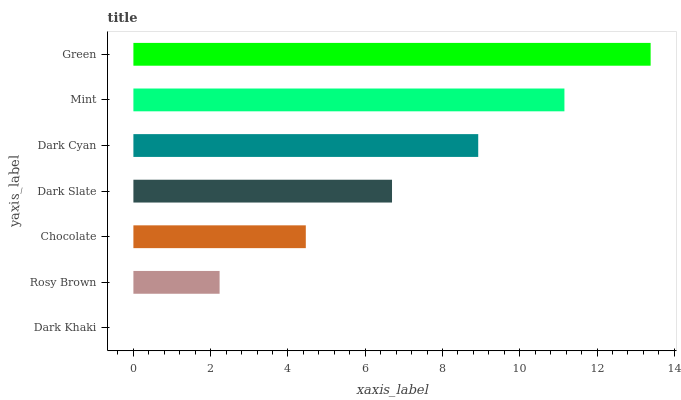Is Dark Khaki the minimum?
Answer yes or no. Yes. Is Green the maximum?
Answer yes or no. Yes. Is Rosy Brown the minimum?
Answer yes or no. No. Is Rosy Brown the maximum?
Answer yes or no. No. Is Rosy Brown greater than Dark Khaki?
Answer yes or no. Yes. Is Dark Khaki less than Rosy Brown?
Answer yes or no. Yes. Is Dark Khaki greater than Rosy Brown?
Answer yes or no. No. Is Rosy Brown less than Dark Khaki?
Answer yes or no. No. Is Dark Slate the high median?
Answer yes or no. Yes. Is Dark Slate the low median?
Answer yes or no. Yes. Is Mint the high median?
Answer yes or no. No. Is Green the low median?
Answer yes or no. No. 